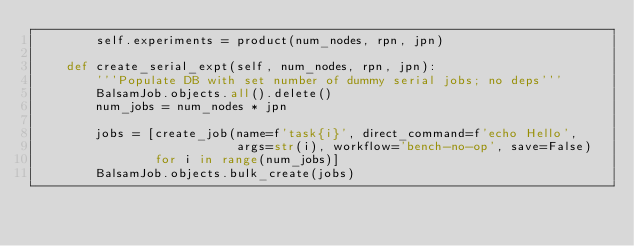<code> <loc_0><loc_0><loc_500><loc_500><_Python_>        self.experiments = product(num_nodes, rpn, jpn)

    def create_serial_expt(self, num_nodes, rpn, jpn):
        '''Populate DB with set number of dummy serial jobs; no deps'''
        BalsamJob.objects.all().delete()
        num_jobs = num_nodes * jpn

        jobs = [create_job(name=f'task{i}', direct_command=f'echo Hello',
                           args=str(i), workflow='bench-no-op', save=False)
                for i in range(num_jobs)]
        BalsamJob.objects.bulk_create(jobs)</code> 